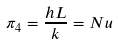<formula> <loc_0><loc_0><loc_500><loc_500>\pi _ { 4 } = \frac { h L } { k } = N u</formula> 